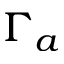<formula> <loc_0><loc_0><loc_500><loc_500>\Gamma _ { a }</formula> 